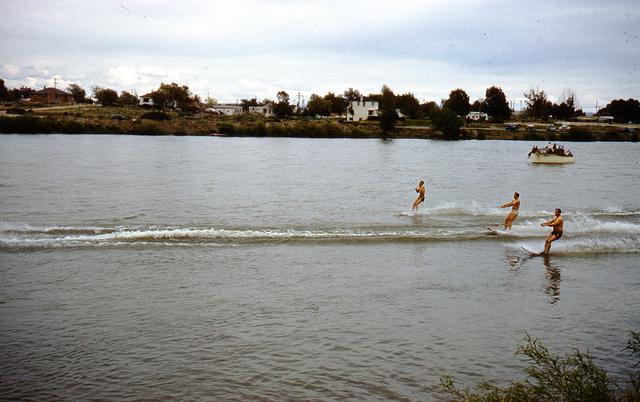Why are the men reaching forward while on skis? waterskiing 